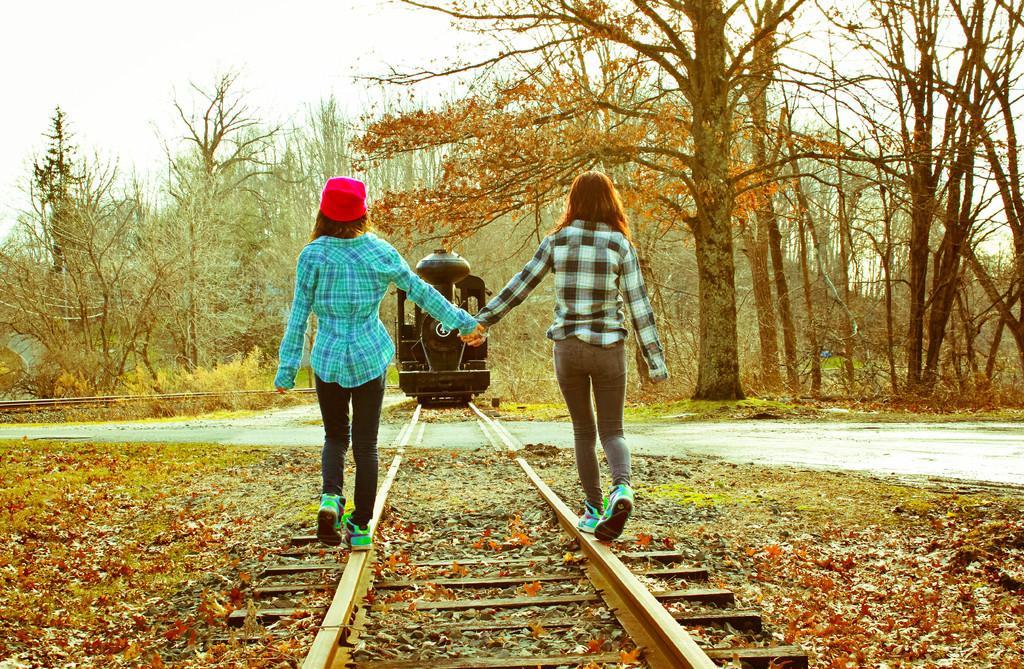Can you describe this image briefly? In this image there are two persons standing on the railway track in middle of this image and there is a train in middle of this image and there are some trees in the background. There is a railway track as we can see in the bottom of this image and there is a sky on the top of this image. 